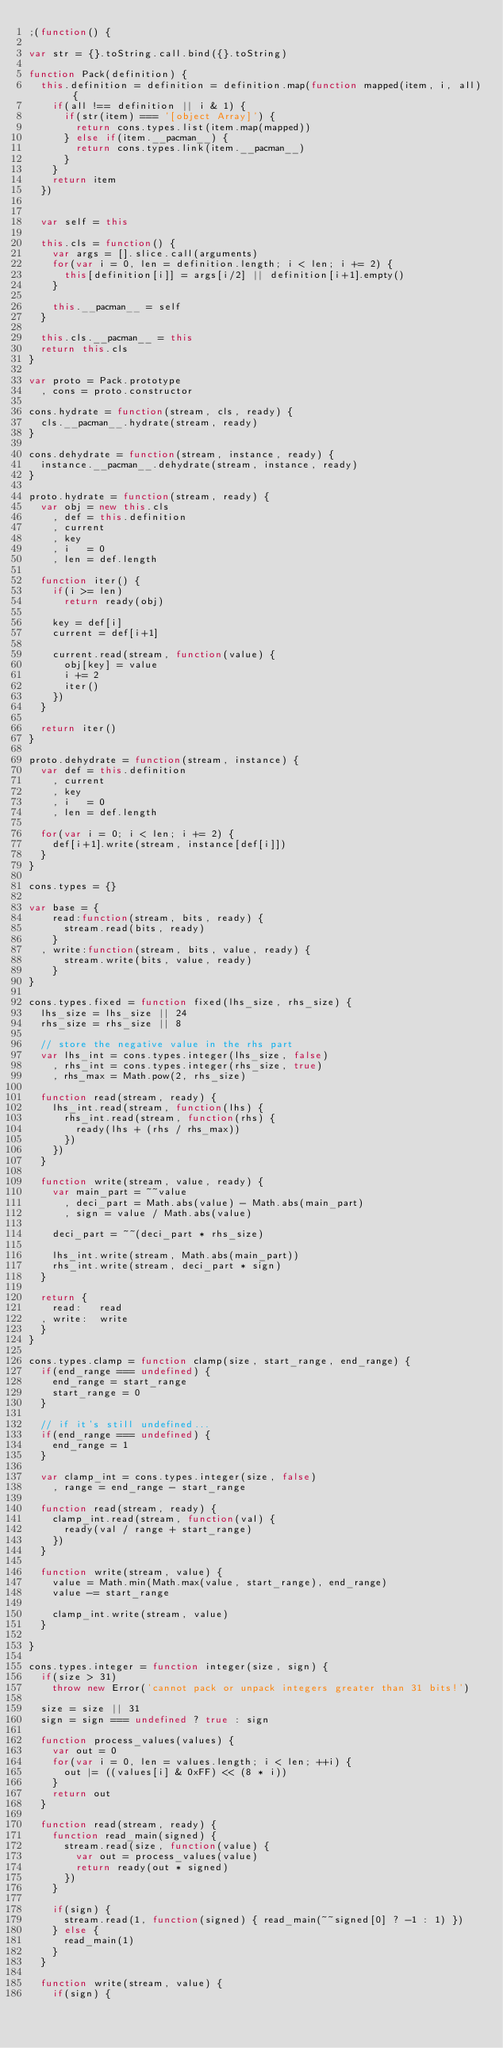Convert code to text. <code><loc_0><loc_0><loc_500><loc_500><_JavaScript_>;(function() { 

var str = {}.toString.call.bind({}.toString)

function Pack(definition) {
  this.definition = definition = definition.map(function mapped(item, i, all) {
    if(all !== definition || i & 1) {
      if(str(item) === '[object Array]') {
        return cons.types.list(item.map(mapped)) 
      } else if(item.__pacman__) {
        return cons.types.link(item.__pacman__)
      }
    }
    return item
  })


  var self = this

  this.cls = function() {
    var args = [].slice.call(arguments)
    for(var i = 0, len = definition.length; i < len; i += 2) {
      this[definition[i]] = args[i/2] || definition[i+1].empty()
    }

    this.__pacman__ = self
  }

  this.cls.__pacman__ = this
  return this.cls
}

var proto = Pack.prototype
  , cons = proto.constructor

cons.hydrate = function(stream, cls, ready) {
  cls.__pacman__.hydrate(stream, ready)
}

cons.dehydrate = function(stream, instance, ready) {
  instance.__pacman__.dehydrate(stream, instance, ready)
}

proto.hydrate = function(stream, ready) {
  var obj = new this.cls
    , def = this.definition
    , current
    , key
    , i   = 0
    , len = def.length

  function iter() {
    if(i >= len)
      return ready(obj)

    key = def[i]
    current = def[i+1]

    current.read(stream, function(value) {
      obj[key] = value
      i += 2
      iter()
    })
  }

  return iter()
}

proto.dehydrate = function(stream, instance) {
  var def = this.definition
    , current
    , key
    , i   = 0
    , len = def.length

  for(var i = 0; i < len; i += 2) {
    def[i+1].write(stream, instance[def[i]])
  }
}

cons.types = {}

var base = {
    read:function(stream, bits, ready) {
      stream.read(bits, ready)
    }
  , write:function(stream, bits, value, ready) {
      stream.write(bits, value, ready)
    }
}

cons.types.fixed = function fixed(lhs_size, rhs_size) {
  lhs_size = lhs_size || 24
  rhs_size = rhs_size || 8

  // store the negative value in the rhs part
  var lhs_int = cons.types.integer(lhs_size, false)
    , rhs_int = cons.types.integer(rhs_size, true)
    , rhs_max = Math.pow(2, rhs_size)

  function read(stream, ready) {
    lhs_int.read(stream, function(lhs) {
      rhs_int.read(stream, function(rhs) {
        ready(lhs + (rhs / rhs_max))
      })
    })    
  }

  function write(stream, value, ready) {
    var main_part = ~~value
      , deci_part = Math.abs(value) - Math.abs(main_part)
      , sign = value / Math.abs(value)

    deci_part = ~~(deci_part * rhs_size) 

    lhs_int.write(stream, Math.abs(main_part))
    rhs_int.write(stream, deci_part * sign)
  }

  return {
    read:   read
  , write:  write
  }
}

cons.types.clamp = function clamp(size, start_range, end_range) {
  if(end_range === undefined) {
    end_range = start_range
    start_range = 0
  }

  // if it's still undefined...
  if(end_range === undefined) {
    end_range = 1
  }

  var clamp_int = cons.types.integer(size, false)
    , range = end_range - start_range

  function read(stream, ready) {
    clamp_int.read(stream, function(val) {
      ready(val / range + start_range)
    })
  }

  function write(stream, value) {
    value = Math.min(Math.max(value, start_range), end_range)
    value -= start_range

    clamp_int.write(stream, value)
  }

}

cons.types.integer = function integer(size, sign) {
  if(size > 31)
    throw new Error('cannot pack or unpack integers greater than 31 bits!')

  size = size || 31
  sign = sign === undefined ? true : sign

  function process_values(values) {
    var out = 0
    for(var i = 0, len = values.length; i < len; ++i) {
      out |= ((values[i] & 0xFF) << (8 * i))
    }
    return out
  }

  function read(stream, ready) {
    function read_main(signed) {
      stream.read(size, function(value) {
        var out = process_values(value)
        return ready(out * signed)
      })
    }

    if(sign) {
      stream.read(1, function(signed) { read_main(~~signed[0] ? -1 : 1) })
    } else {
      read_main(1)
    }
  }

  function write(stream, value) {
    if(sign) {</code> 